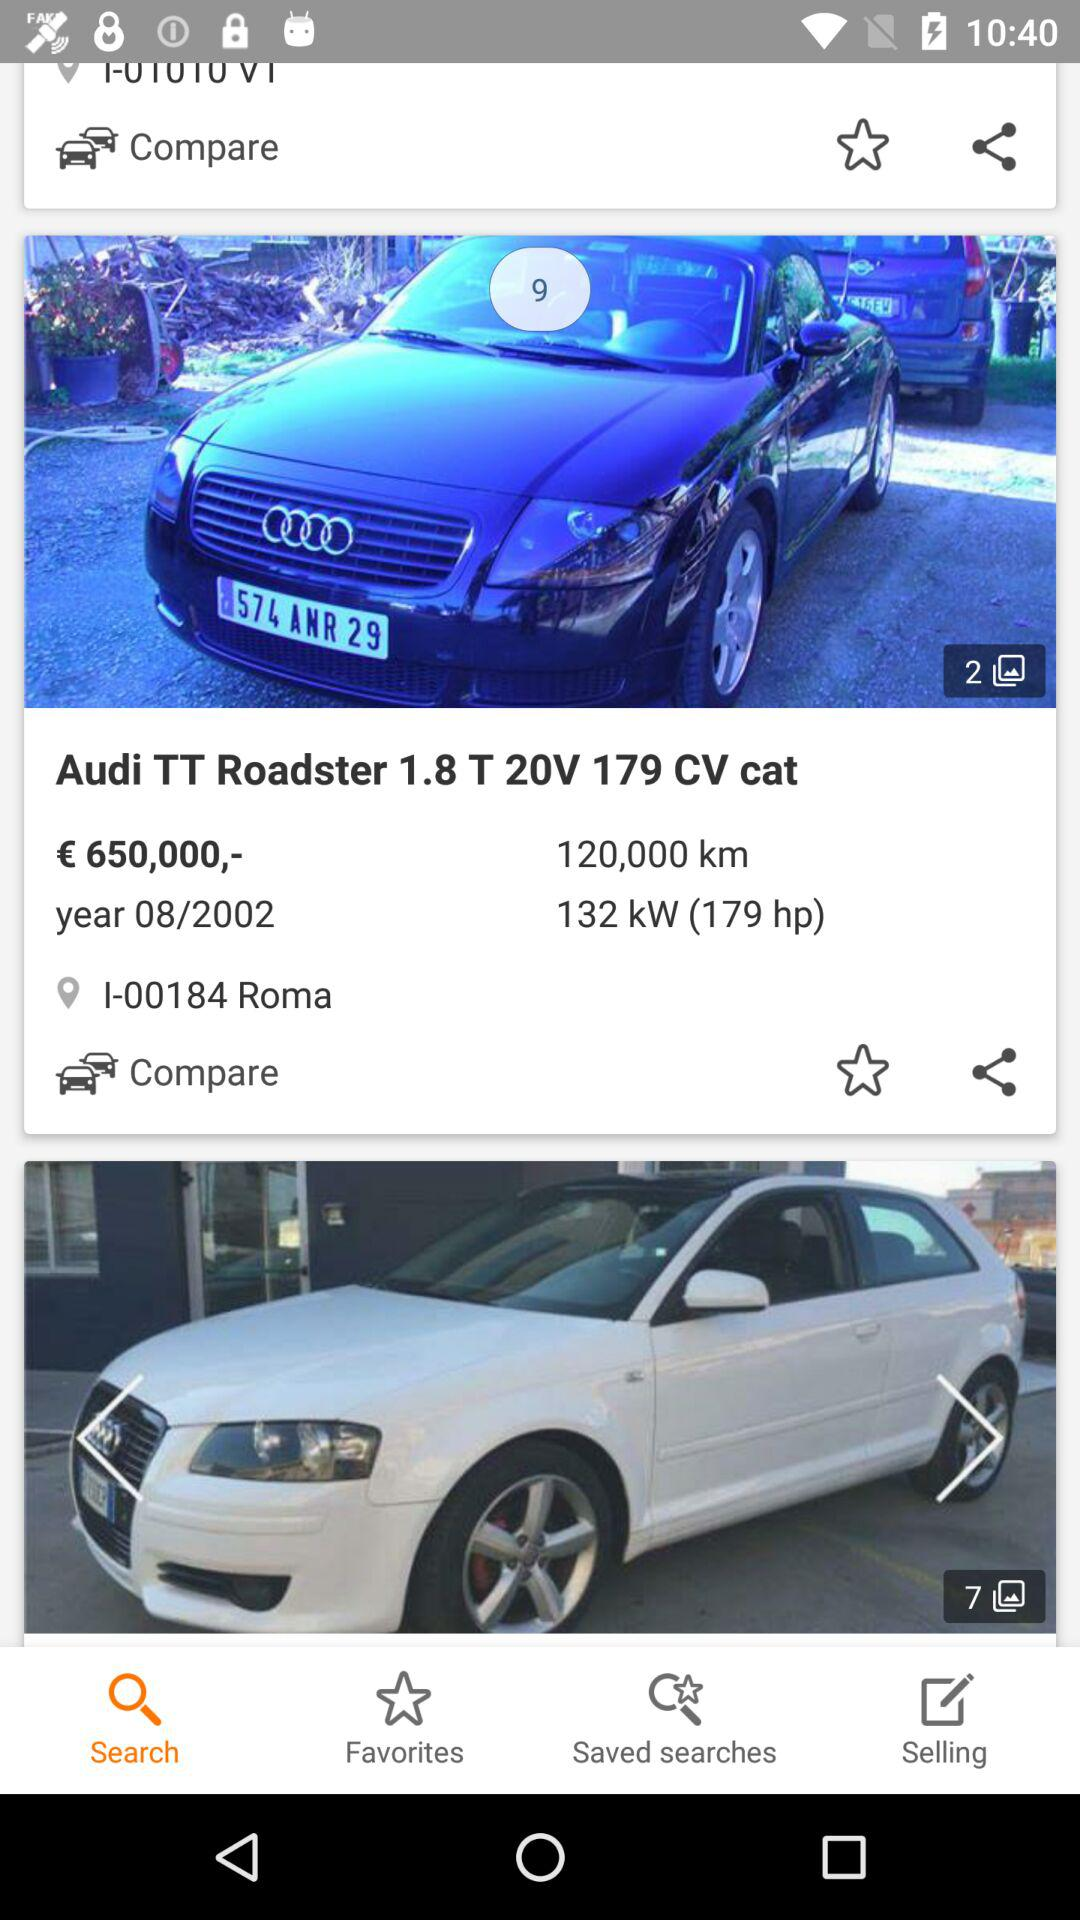What is the price of the "Audi TT Roadster"? The price is €650,000. 